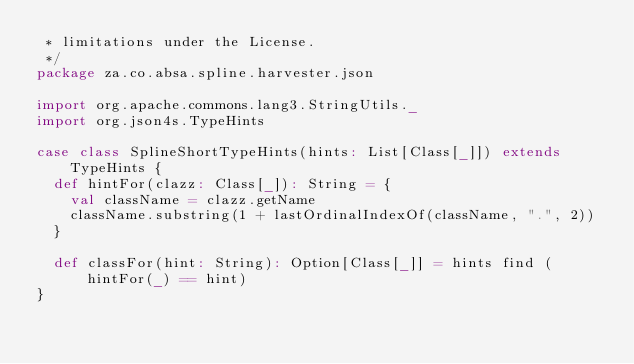<code> <loc_0><loc_0><loc_500><loc_500><_Scala_> * limitations under the License.
 */
package za.co.absa.spline.harvester.json

import org.apache.commons.lang3.StringUtils._
import org.json4s.TypeHints

case class SplineShortTypeHints(hints: List[Class[_]]) extends TypeHints {
  def hintFor(clazz: Class[_]): String = {
    val className = clazz.getName
    className.substring(1 + lastOrdinalIndexOf(className, ".", 2))
  }

  def classFor(hint: String): Option[Class[_]] = hints find (hintFor(_) == hint)
}</code> 